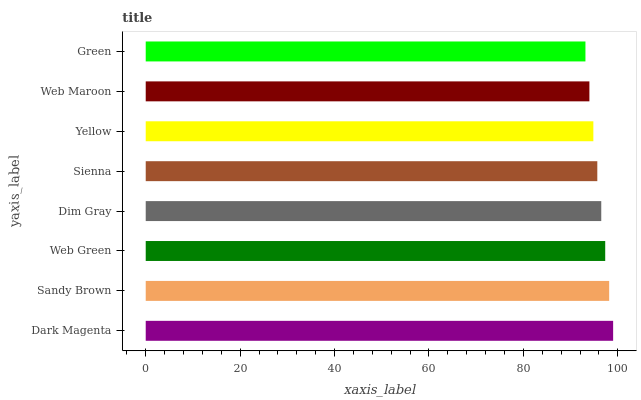Is Green the minimum?
Answer yes or no. Yes. Is Dark Magenta the maximum?
Answer yes or no. Yes. Is Sandy Brown the minimum?
Answer yes or no. No. Is Sandy Brown the maximum?
Answer yes or no. No. Is Dark Magenta greater than Sandy Brown?
Answer yes or no. Yes. Is Sandy Brown less than Dark Magenta?
Answer yes or no. Yes. Is Sandy Brown greater than Dark Magenta?
Answer yes or no. No. Is Dark Magenta less than Sandy Brown?
Answer yes or no. No. Is Dim Gray the high median?
Answer yes or no. Yes. Is Sienna the low median?
Answer yes or no. Yes. Is Web Maroon the high median?
Answer yes or no. No. Is Dark Magenta the low median?
Answer yes or no. No. 